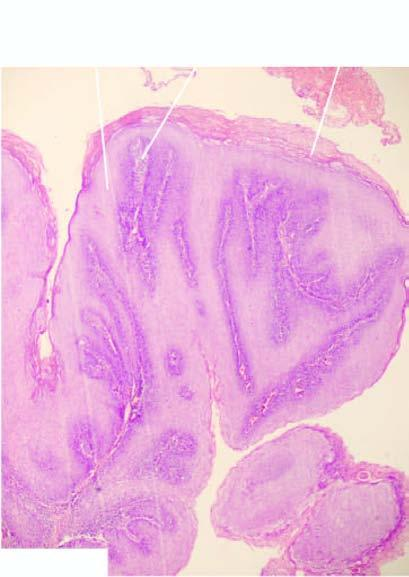re various types of epithelial cells covered with well oriented and orderly layers of squamous cells?
Answer the question using a single word or phrase. No 